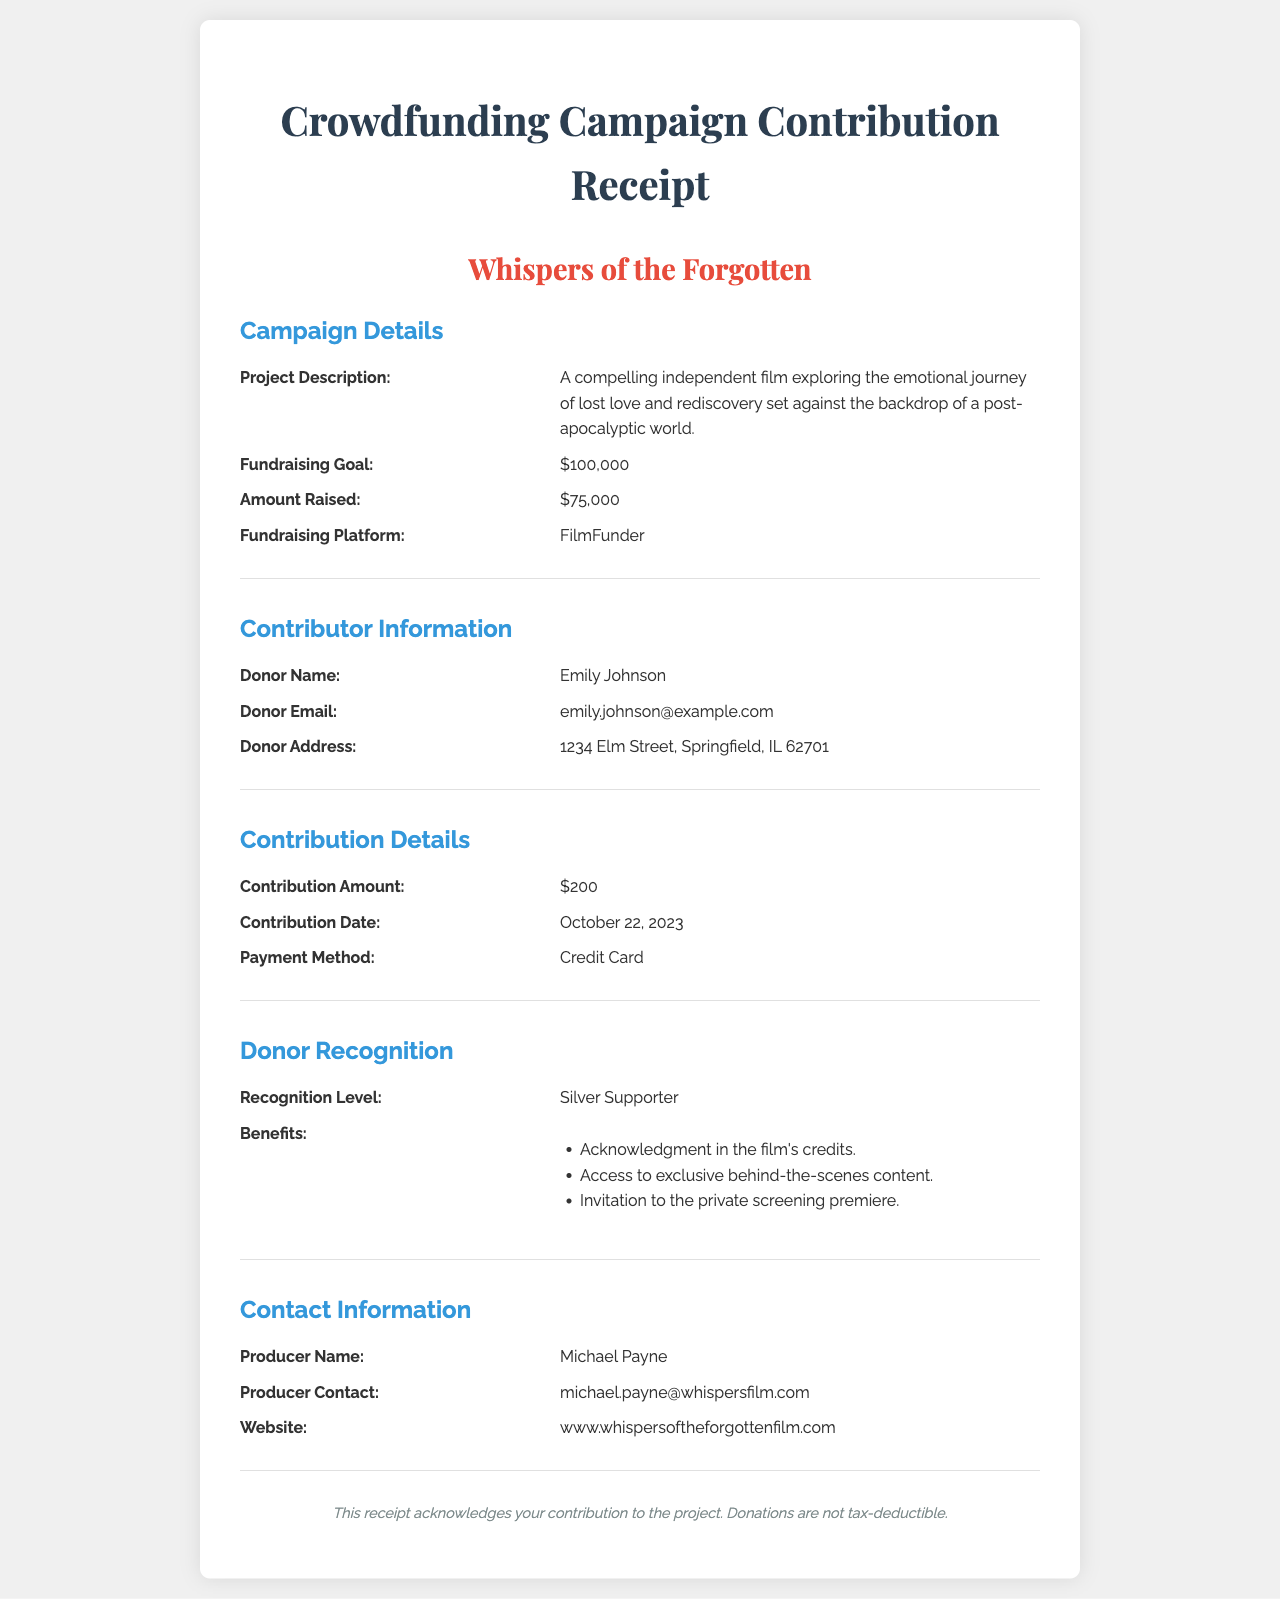what is the project name? The project name is highlighted in the document under "project name."
Answer: Whispers of the Forgotten what is the contribution amount? The contribution amount is specified in the "Contribution Details" section of the document.
Answer: $200 who is the donor? The donor's name is listed under "Contributor Information."
Answer: Emily Johnson what is the fundraising goal? The fundraising goal is stated in the "Campaign Details" section of the document.
Answer: $100,000 what is the recognition level of the donor? The recognition level is mentioned in the "Donor Recognition" section.
Answer: Silver Supporter what date was the contribution made? The contribution date is found in the "Contribution Details" section.
Answer: October 22, 2023 what payment method was used? The payment method is indicated in the "Contribution Details" section.
Answer: Credit Card which platform was used for fundraising? The fundraising platform is described in the "Campaign Details" section.
Answer: FilmFunder what is the email of the producer? The producer's contact information includes their email address, found in the "Contact Information" section.
Answer: michael.payne@whispersfilm.com 